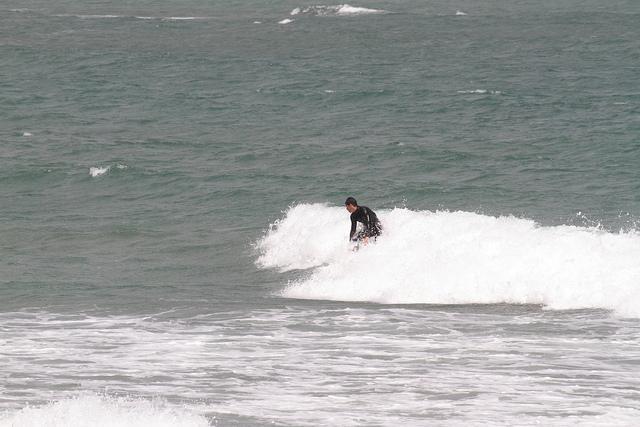How many people are in the water?
Give a very brief answer. 1. How many pairs of scissors are in the picture?
Give a very brief answer. 0. 